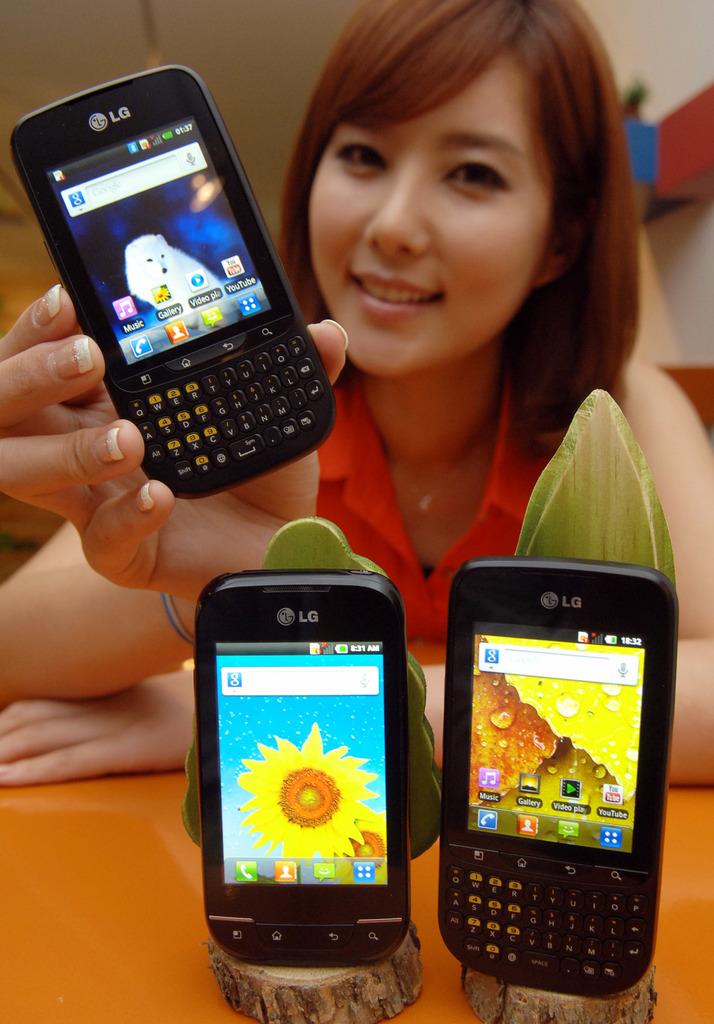What brand are these phones?
Offer a very short reply. Lg. What is the name of the purple app on the phone in person is holding?
Your answer should be compact. Music. 